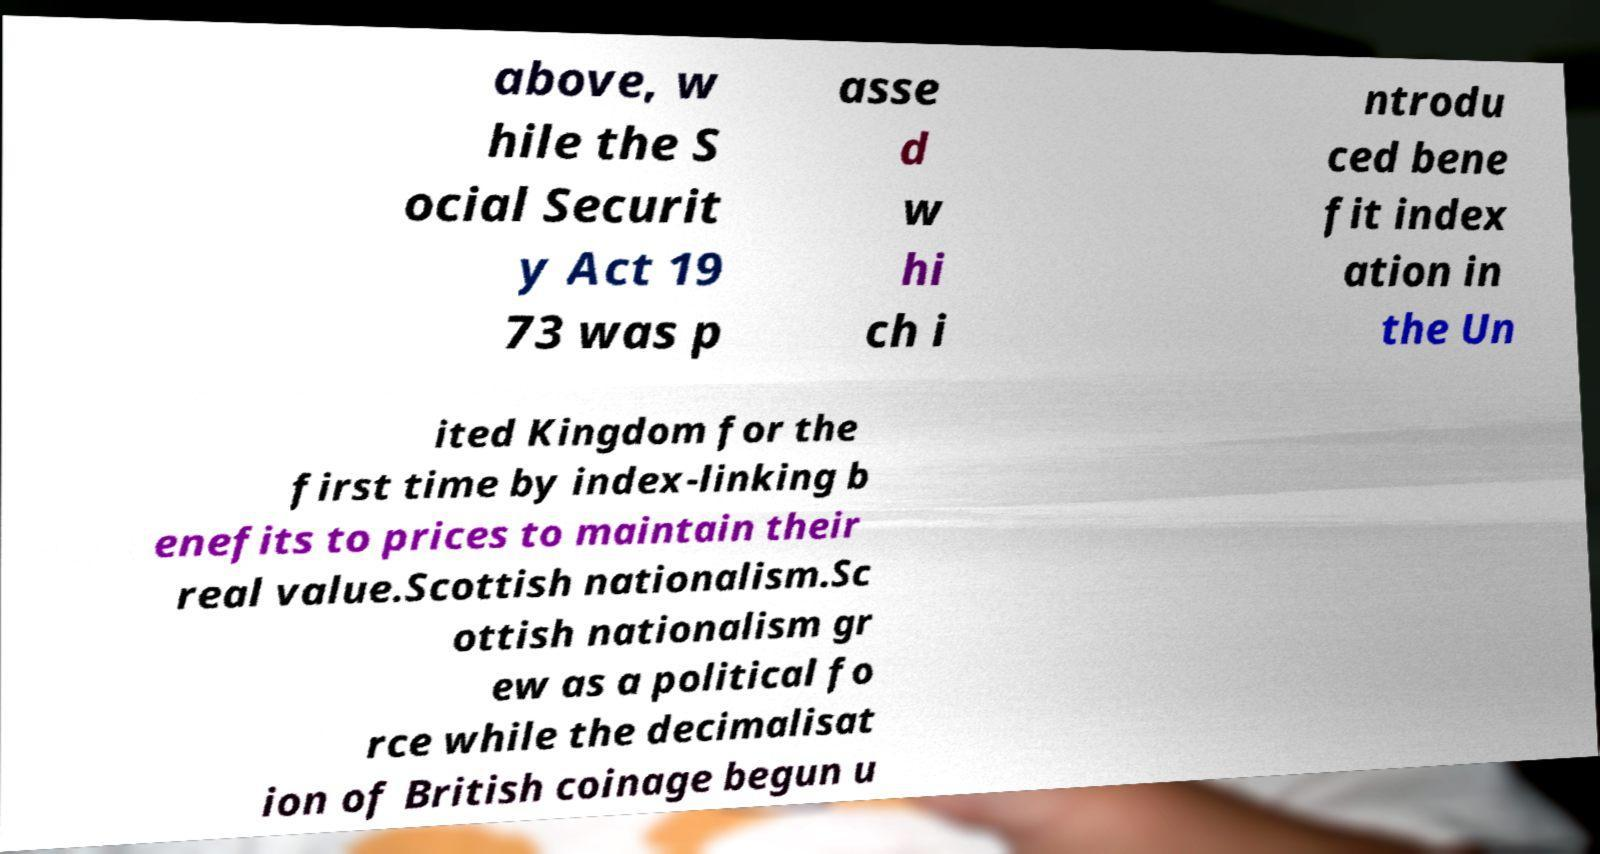I need the written content from this picture converted into text. Can you do that? above, w hile the S ocial Securit y Act 19 73 was p asse d w hi ch i ntrodu ced bene fit index ation in the Un ited Kingdom for the first time by index-linking b enefits to prices to maintain their real value.Scottish nationalism.Sc ottish nationalism gr ew as a political fo rce while the decimalisat ion of British coinage begun u 